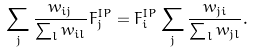Convert formula to latex. <formula><loc_0><loc_0><loc_500><loc_500>\sum _ { j } \frac { w _ { i j } } { \sum _ { l } w _ { i l } } F _ { j } ^ { I P } = F _ { i } ^ { I P } \sum _ { j } \frac { w _ { j i } } { \sum _ { l } w _ { j l } } .</formula> 